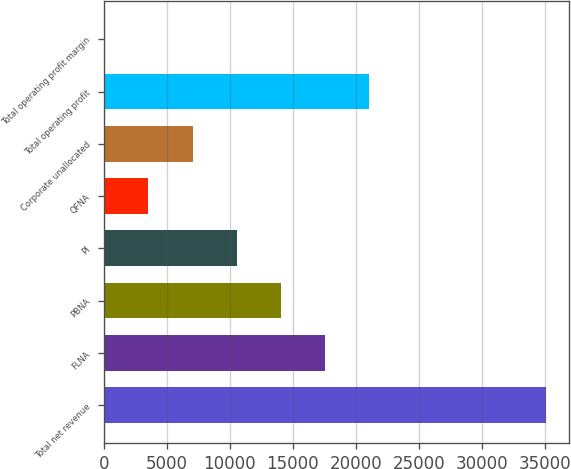Convert chart. <chart><loc_0><loc_0><loc_500><loc_500><bar_chart><fcel>Total net revenue<fcel>FLNA<fcel>PBNA<fcel>PI<fcel>QFNA<fcel>Corporate unallocated<fcel>Total operating profit<fcel>Total operating profit margin<nl><fcel>35137<fcel>17577.8<fcel>14065.9<fcel>10554<fcel>3530.35<fcel>7042.2<fcel>21089.6<fcel>18.5<nl></chart> 